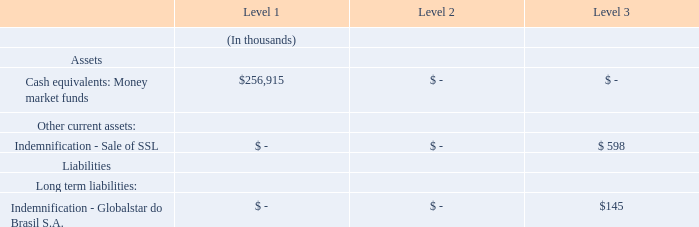Assets and Liabilities Measured at Fair Value
The following table presents our assets and liabilities measured at fair value on a recurring or non-recurring basis at December 31,
2019:
The carrying amount of money market funds approximates fair value as of each reporting date because of the short maturity of those
instruments.
The Company did not have any non-financial assets or non-financial liabilities that were recognized or disclosed at fair value as of
December 31, 2019.
What is the usefulness of the carrying amount of money market funds? Approximates fair value as of each reporting date. What are the fair value of the company's respective non-financial assets and liabilities recognised or disclosed as of December 31, 2019?
Answer scale should be: thousand. 0, 0. What are the company's Level 2 and 3 long term liabilities as at December 31, 2019?
Answer scale should be: thousand. 0, $145. What is the company's net assets measured at fair value as at December 31, 2019?
Answer scale should be: thousand. $256,915 + $598 - $145 
Answer: 257368. What is the fair value of the company's total assets as at December 31, 2019?
Answer scale should be: thousand. $256,915 + $598 
Answer: 257513. What is the total fair value of the company's Level 3 net assets?
Answer scale should be: thousand. $598 - $145 
Answer: 453. 